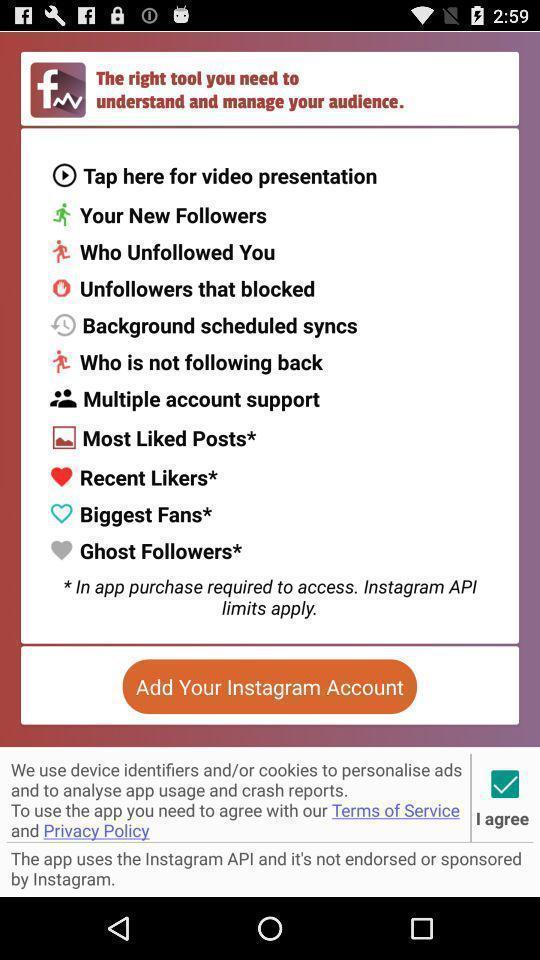Provide a detailed account of this screenshot. Screen showing multiple options. 